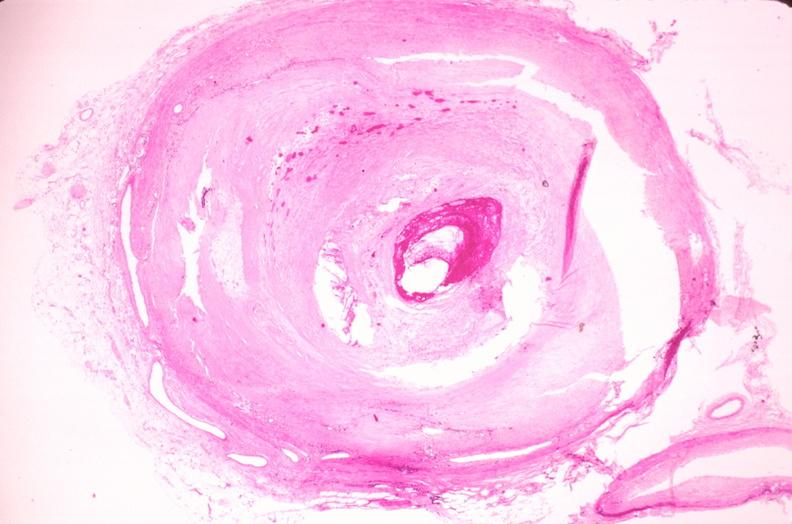what is present?
Answer the question using a single word or phrase. Vasculature 